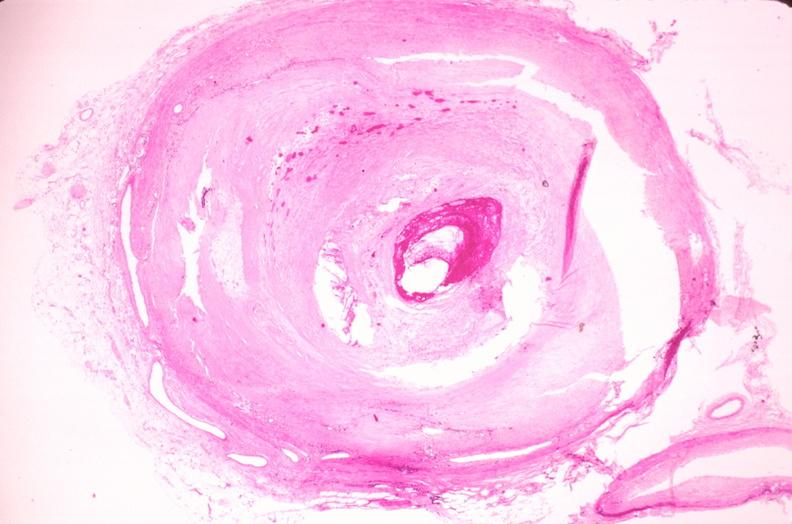what is present?
Answer the question using a single word or phrase. Vasculature 